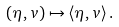<formula> <loc_0><loc_0><loc_500><loc_500>( \eta , v ) \mapsto \langle \eta , v \rangle \, .</formula> 